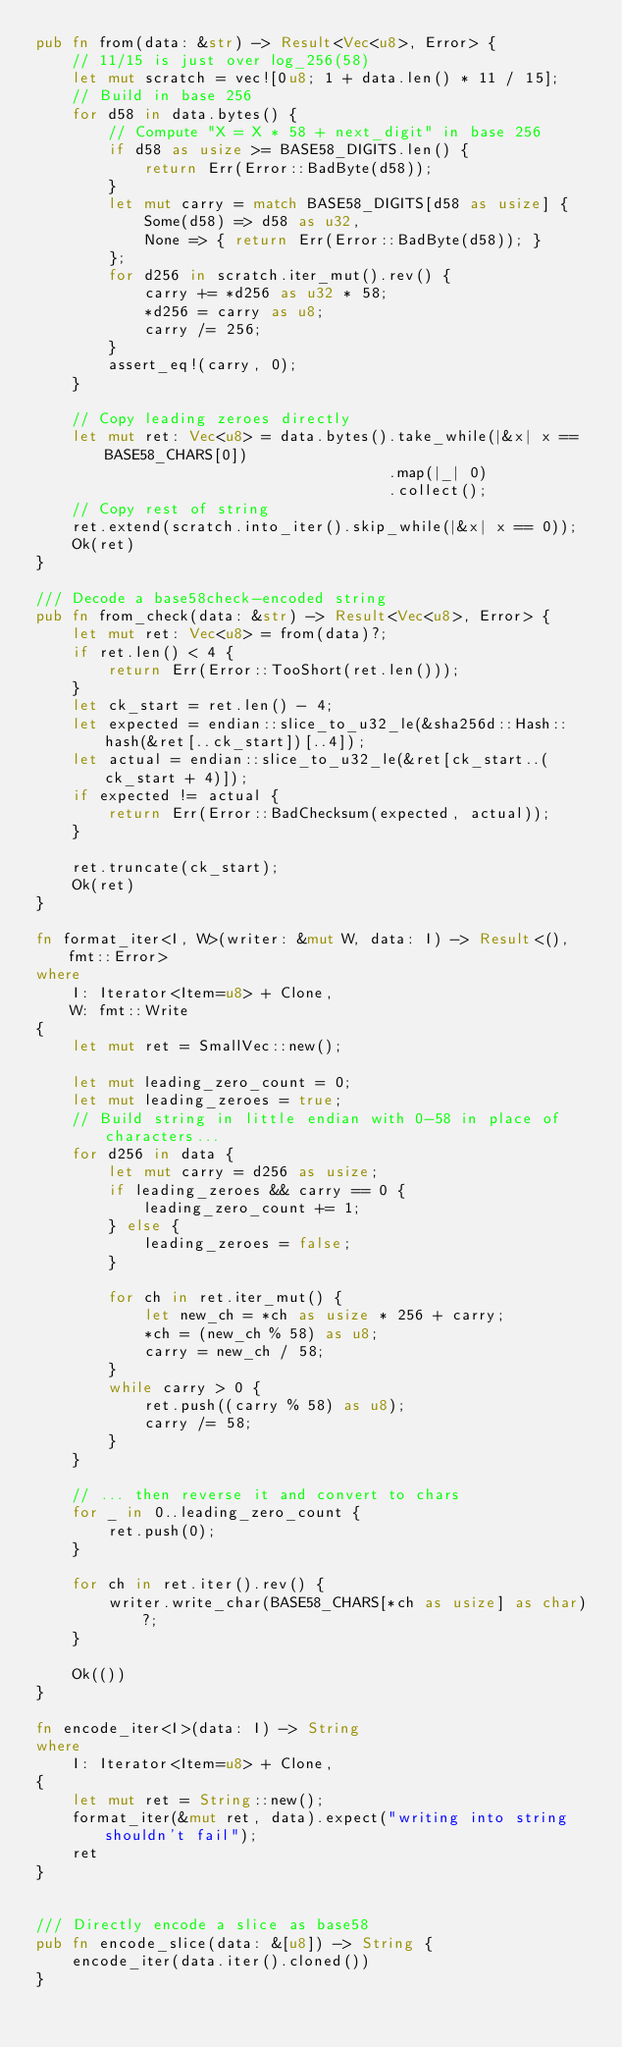Convert code to text. <code><loc_0><loc_0><loc_500><loc_500><_Rust_>pub fn from(data: &str) -> Result<Vec<u8>, Error> {
    // 11/15 is just over log_256(58)
    let mut scratch = vec![0u8; 1 + data.len() * 11 / 15];
    // Build in base 256
    for d58 in data.bytes() {
        // Compute "X = X * 58 + next_digit" in base 256
        if d58 as usize >= BASE58_DIGITS.len() {
            return Err(Error::BadByte(d58));
        }
        let mut carry = match BASE58_DIGITS[d58 as usize] {
            Some(d58) => d58 as u32,
            None => { return Err(Error::BadByte(d58)); }
        };
        for d256 in scratch.iter_mut().rev() {
            carry += *d256 as u32 * 58;
            *d256 = carry as u8;
            carry /= 256;
        }
        assert_eq!(carry, 0);
    }

    // Copy leading zeroes directly
    let mut ret: Vec<u8> = data.bytes().take_while(|&x| x == BASE58_CHARS[0])
                                       .map(|_| 0)
                                       .collect();
    // Copy rest of string
    ret.extend(scratch.into_iter().skip_while(|&x| x == 0));
    Ok(ret)
}

/// Decode a base58check-encoded string
pub fn from_check(data: &str) -> Result<Vec<u8>, Error> {
    let mut ret: Vec<u8> = from(data)?;
    if ret.len() < 4 {
        return Err(Error::TooShort(ret.len()));
    }
    let ck_start = ret.len() - 4;
    let expected = endian::slice_to_u32_le(&sha256d::Hash::hash(&ret[..ck_start])[..4]);
    let actual = endian::slice_to_u32_le(&ret[ck_start..(ck_start + 4)]);
    if expected != actual {
        return Err(Error::BadChecksum(expected, actual));
    }

    ret.truncate(ck_start);
    Ok(ret)
}

fn format_iter<I, W>(writer: &mut W, data: I) -> Result<(), fmt::Error>
where
    I: Iterator<Item=u8> + Clone,
    W: fmt::Write
{
    let mut ret = SmallVec::new();

    let mut leading_zero_count = 0;
    let mut leading_zeroes = true;
    // Build string in little endian with 0-58 in place of characters...
    for d256 in data {
        let mut carry = d256 as usize;
        if leading_zeroes && carry == 0 {
            leading_zero_count += 1;
        } else {
            leading_zeroes = false;
        }

        for ch in ret.iter_mut() {
            let new_ch = *ch as usize * 256 + carry;
            *ch = (new_ch % 58) as u8;
            carry = new_ch / 58;
        }
        while carry > 0 {
            ret.push((carry % 58) as u8);
            carry /= 58;
        }
    }

    // ... then reverse it and convert to chars
    for _ in 0..leading_zero_count {
        ret.push(0);
    }

    for ch in ret.iter().rev() {
        writer.write_char(BASE58_CHARS[*ch as usize] as char)?;
    }

    Ok(())
}

fn encode_iter<I>(data: I) -> String
where
    I: Iterator<Item=u8> + Clone,
{
    let mut ret = String::new();
    format_iter(&mut ret, data).expect("writing into string shouldn't fail");
    ret
}


/// Directly encode a slice as base58
pub fn encode_slice(data: &[u8]) -> String {
    encode_iter(data.iter().cloned())
}
</code> 